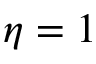<formula> <loc_0><loc_0><loc_500><loc_500>\eta = 1</formula> 